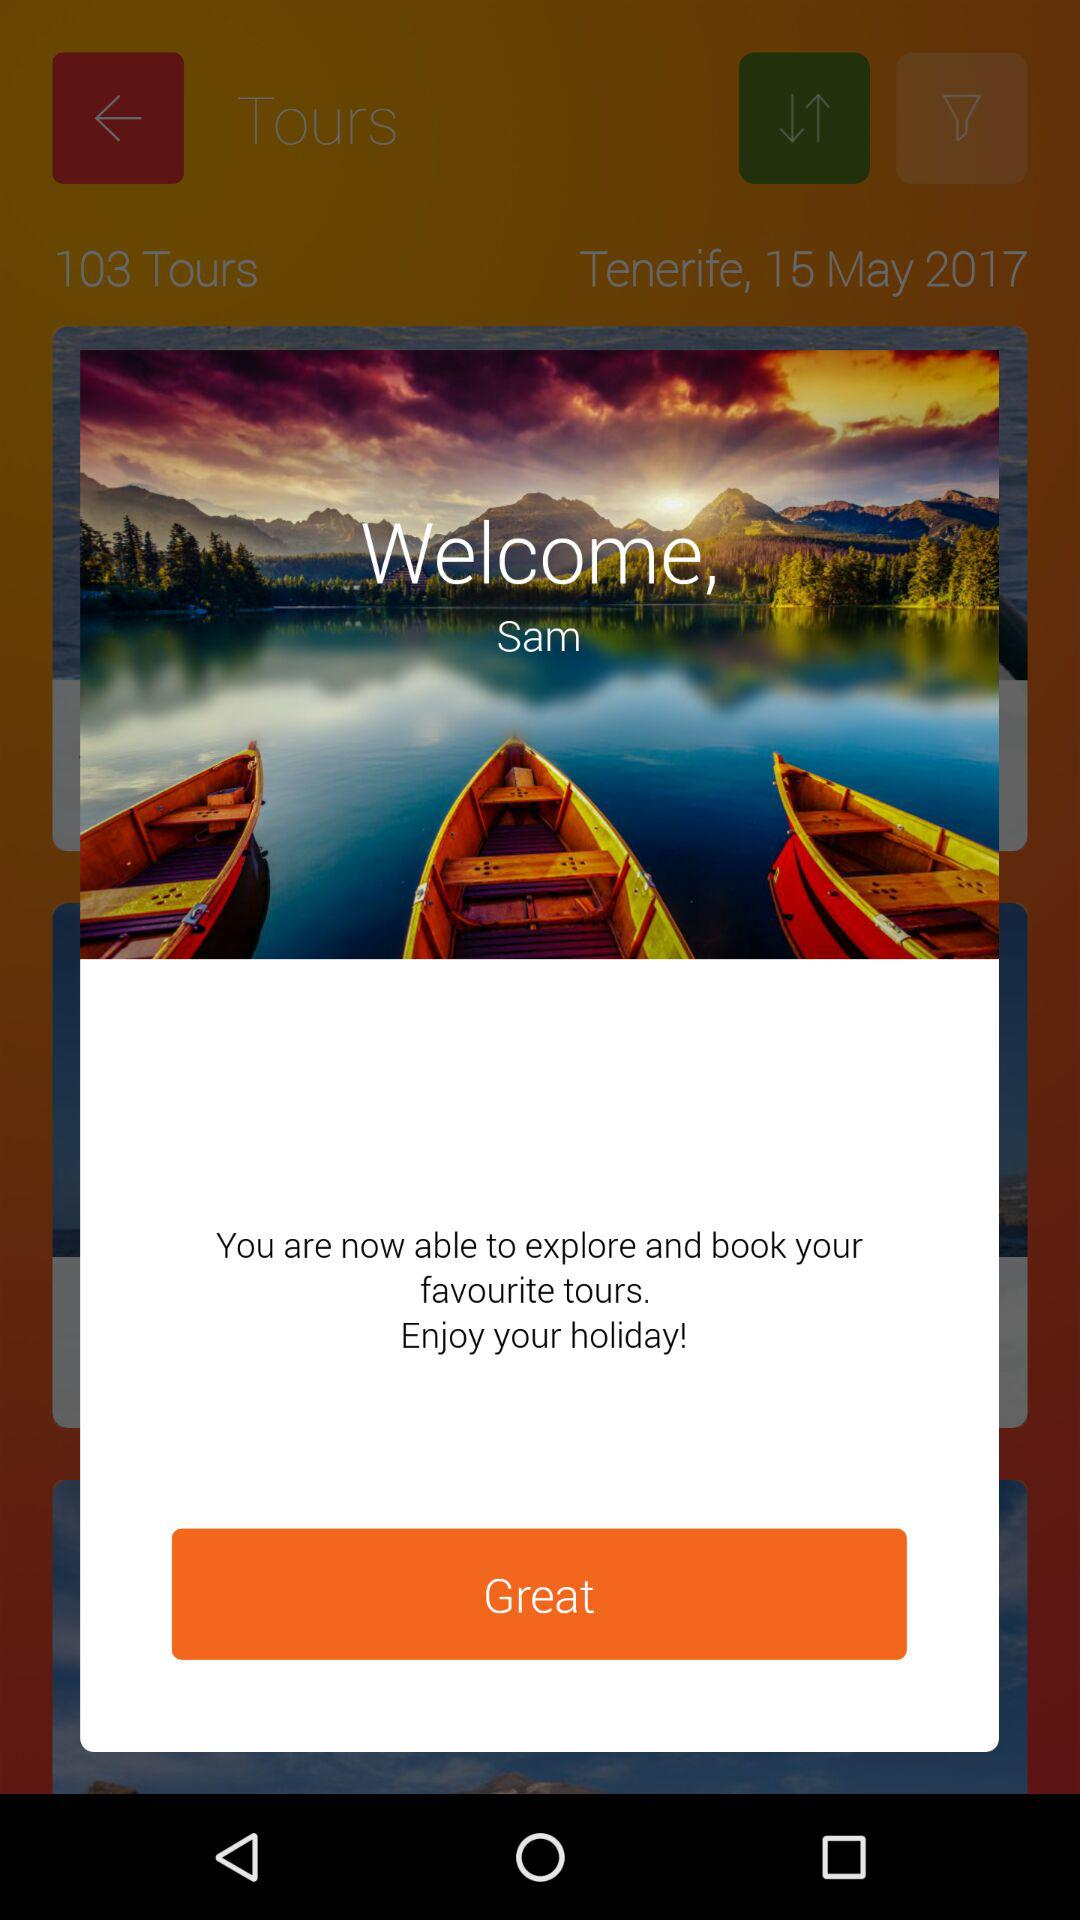What is the date? The date is May 15, 2017. 